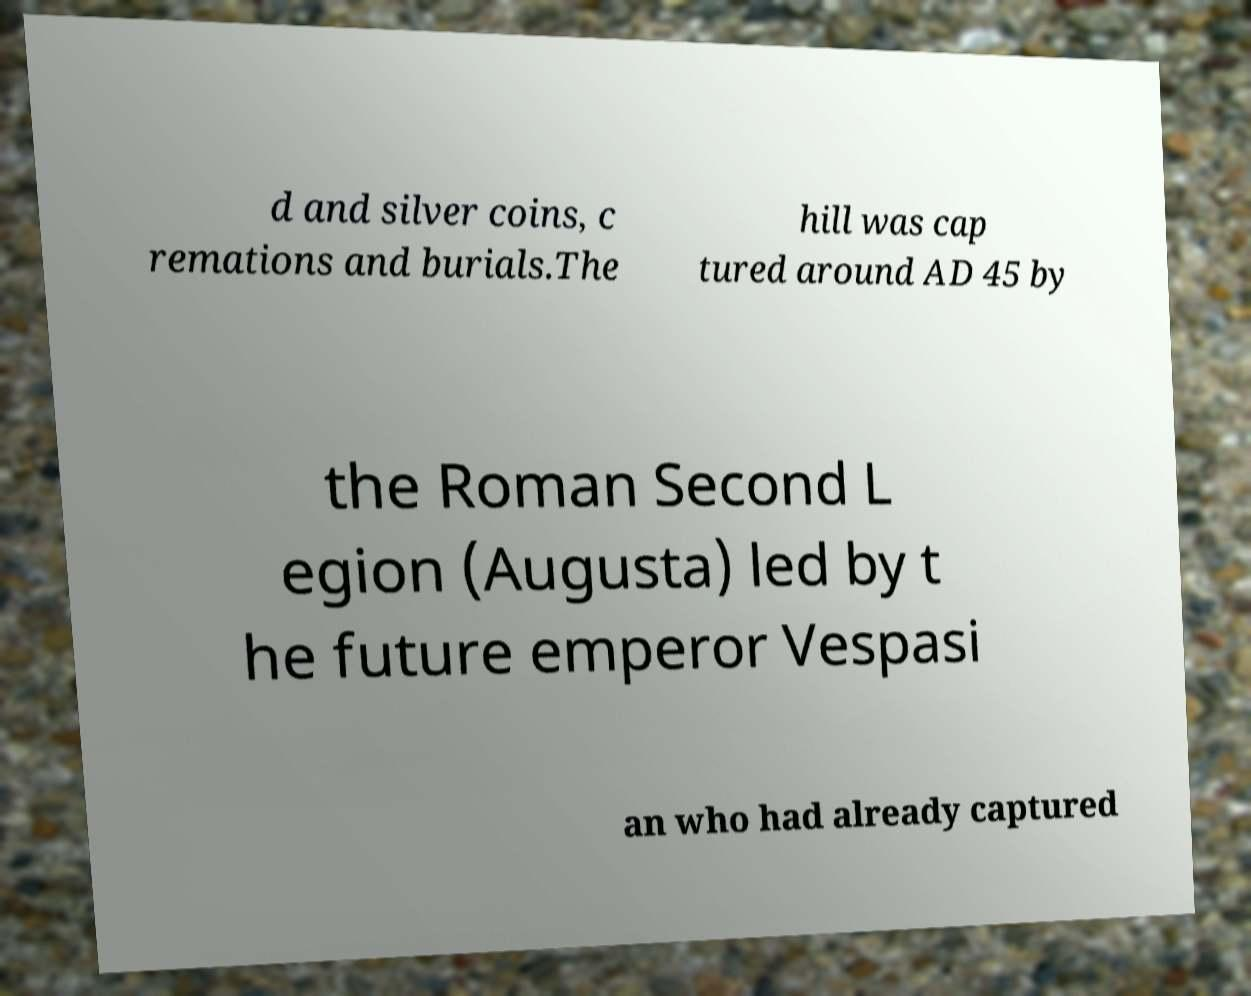Can you accurately transcribe the text from the provided image for me? d and silver coins, c remations and burials.The hill was cap tured around AD 45 by the Roman Second L egion (Augusta) led by t he future emperor Vespasi an who had already captured 